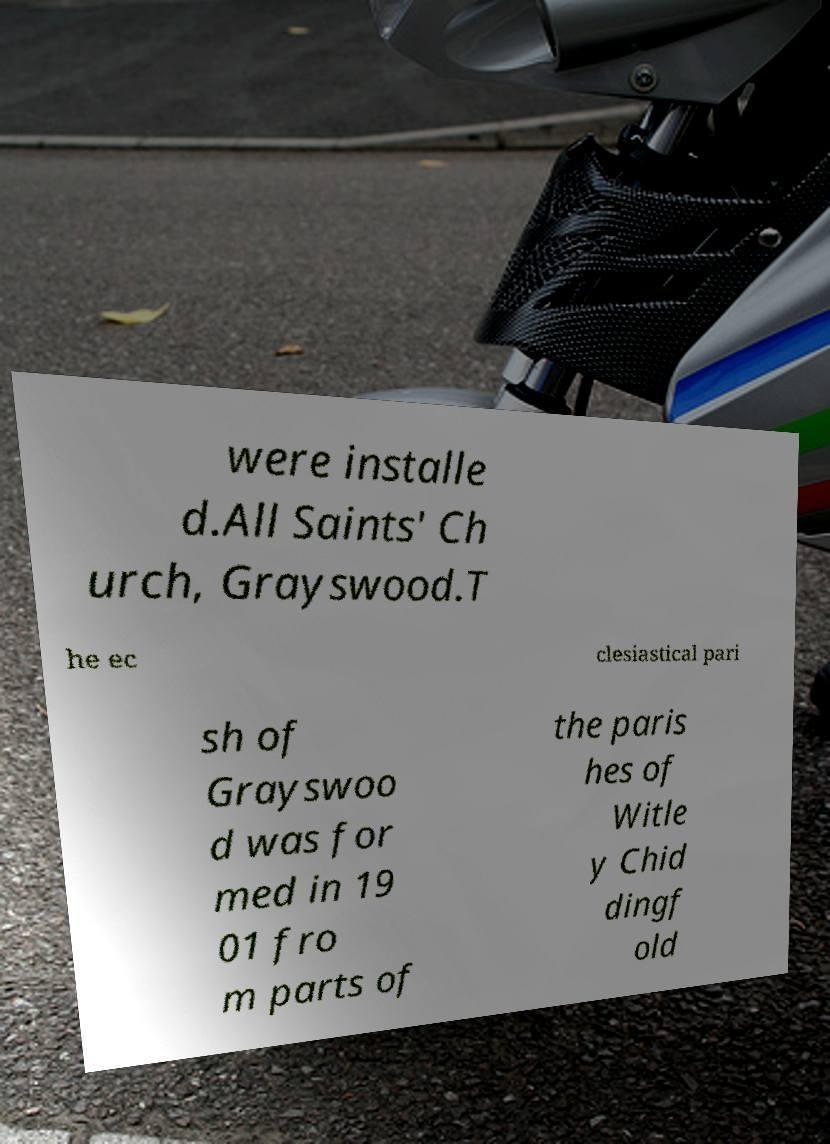There's text embedded in this image that I need extracted. Can you transcribe it verbatim? were installe d.All Saints' Ch urch, Grayswood.T he ec clesiastical pari sh of Grayswoo d was for med in 19 01 fro m parts of the paris hes of Witle y Chid dingf old 